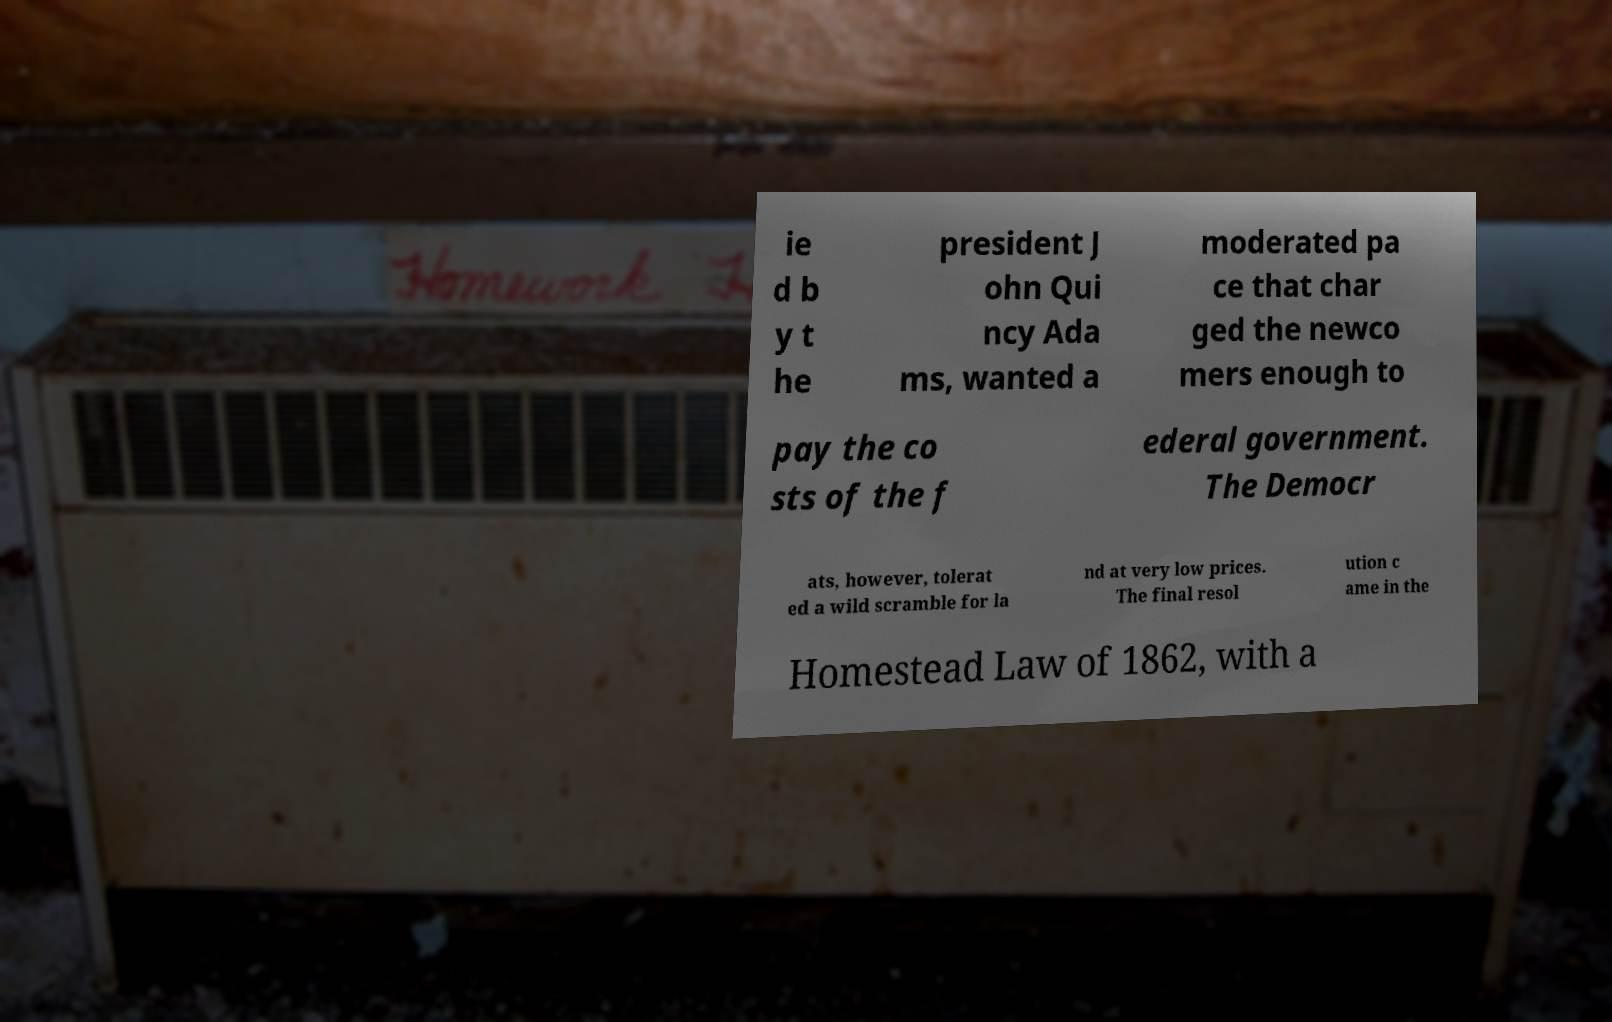Please identify and transcribe the text found in this image. ie d b y t he president J ohn Qui ncy Ada ms, wanted a moderated pa ce that char ged the newco mers enough to pay the co sts of the f ederal government. The Democr ats, however, tolerat ed a wild scramble for la nd at very low prices. The final resol ution c ame in the Homestead Law of 1862, with a 